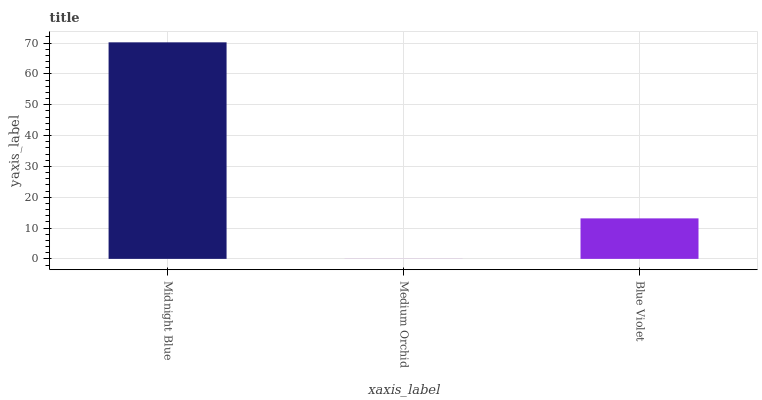Is Medium Orchid the minimum?
Answer yes or no. Yes. Is Midnight Blue the maximum?
Answer yes or no. Yes. Is Blue Violet the minimum?
Answer yes or no. No. Is Blue Violet the maximum?
Answer yes or no. No. Is Blue Violet greater than Medium Orchid?
Answer yes or no. Yes. Is Medium Orchid less than Blue Violet?
Answer yes or no. Yes. Is Medium Orchid greater than Blue Violet?
Answer yes or no. No. Is Blue Violet less than Medium Orchid?
Answer yes or no. No. Is Blue Violet the high median?
Answer yes or no. Yes. Is Blue Violet the low median?
Answer yes or no. Yes. Is Medium Orchid the high median?
Answer yes or no. No. Is Midnight Blue the low median?
Answer yes or no. No. 